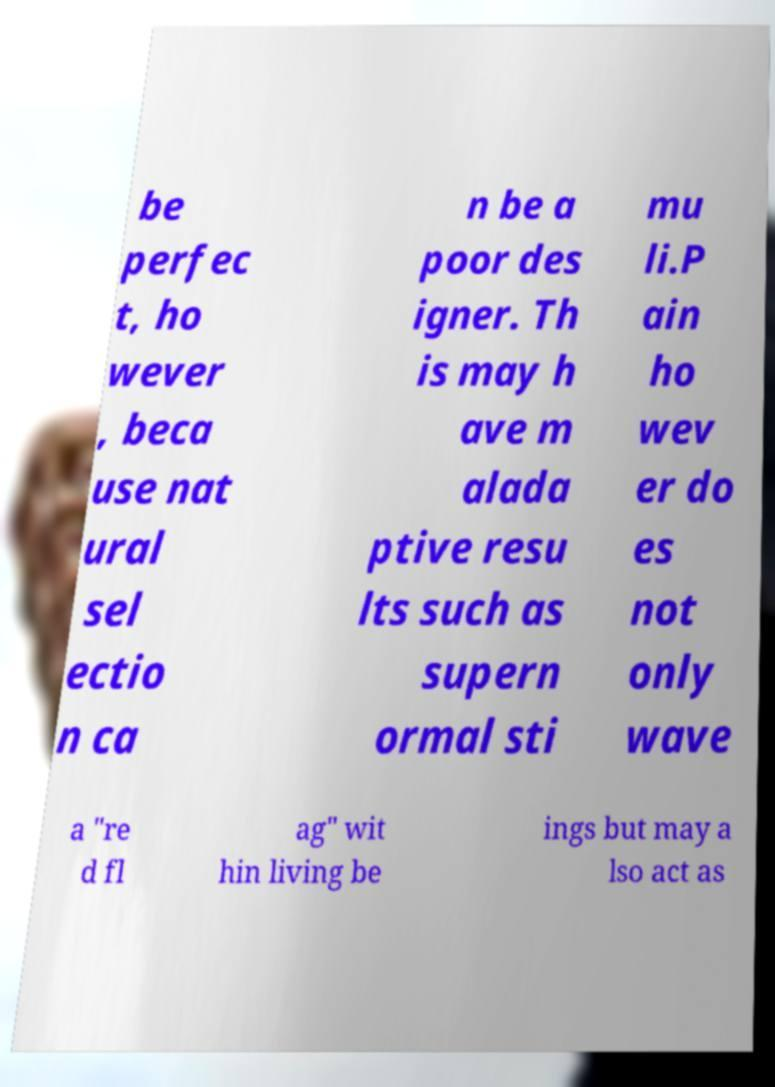Can you read and provide the text displayed in the image?This photo seems to have some interesting text. Can you extract and type it out for me? be perfec t, ho wever , beca use nat ural sel ectio n ca n be a poor des igner. Th is may h ave m alada ptive resu lts such as supern ormal sti mu li.P ain ho wev er do es not only wave a "re d fl ag" wit hin living be ings but may a lso act as 